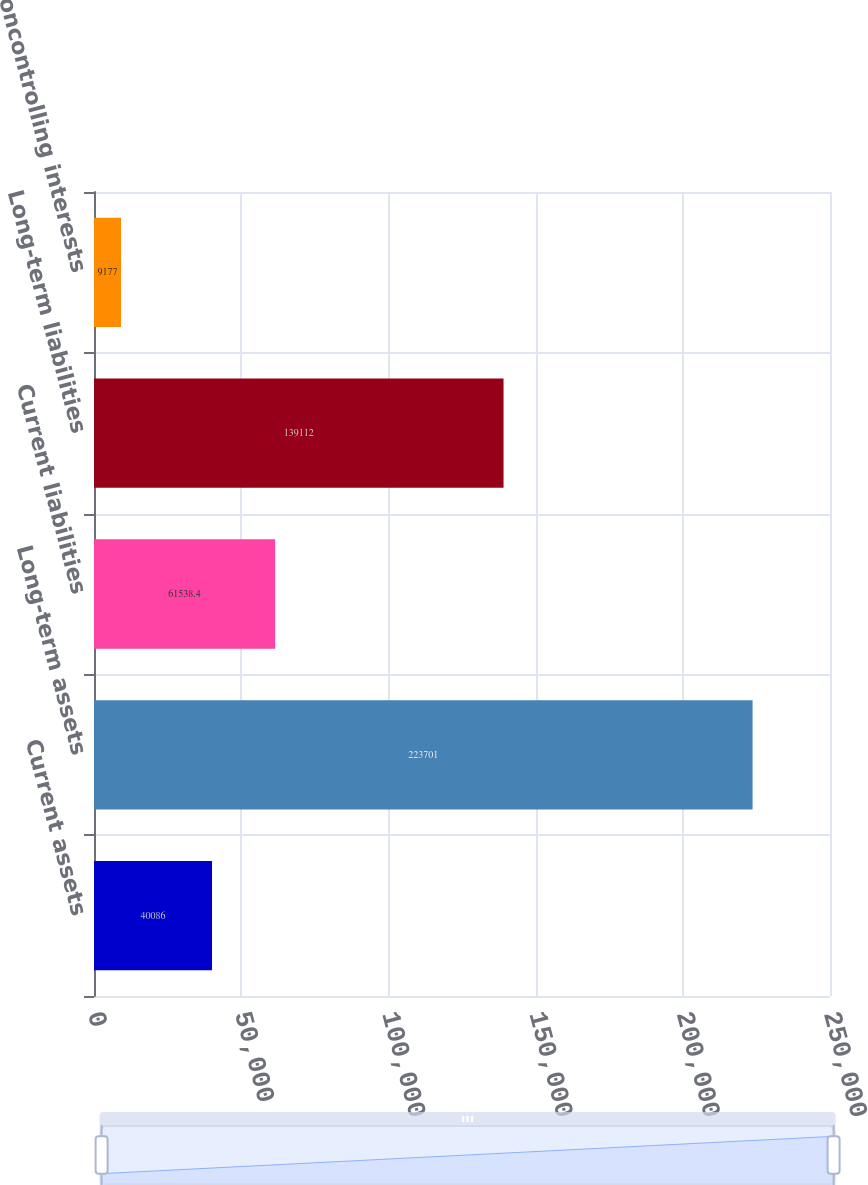<chart> <loc_0><loc_0><loc_500><loc_500><bar_chart><fcel>Current assets<fcel>Long-term assets<fcel>Current liabilities<fcel>Long-term liabilities<fcel>Noncontrolling interests<nl><fcel>40086<fcel>223701<fcel>61538.4<fcel>139112<fcel>9177<nl></chart> 